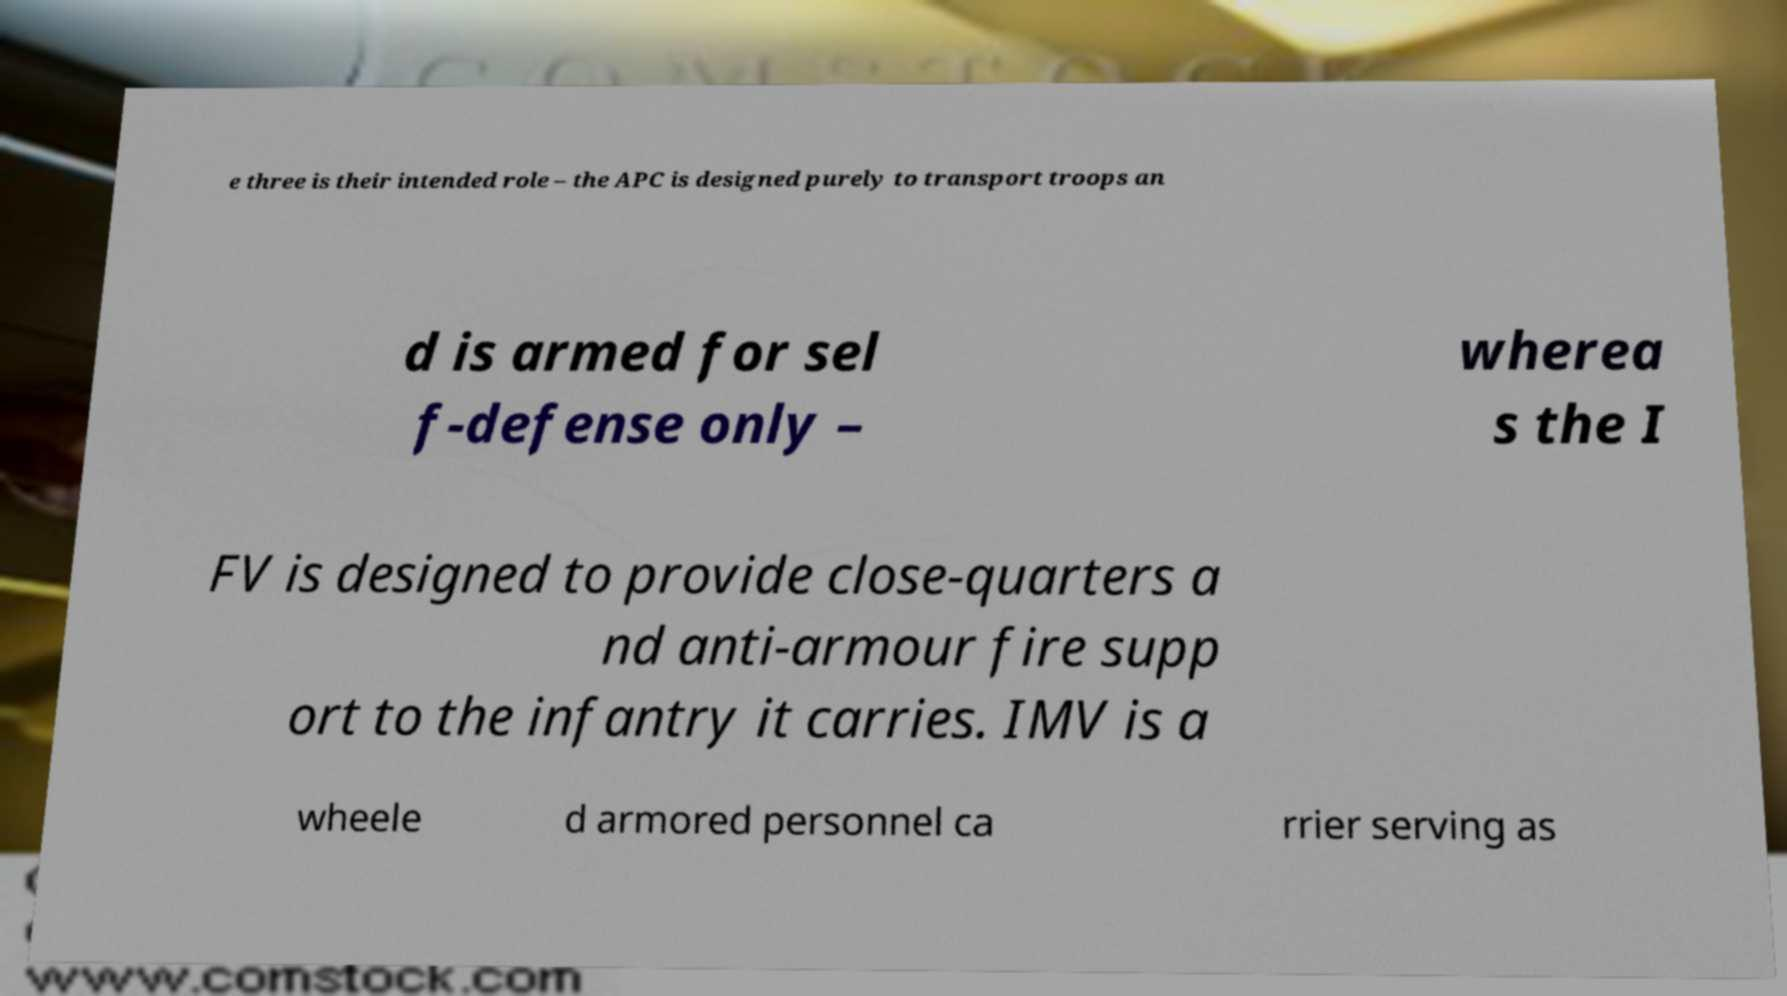What messages or text are displayed in this image? I need them in a readable, typed format. e three is their intended role – the APC is designed purely to transport troops an d is armed for sel f-defense only – wherea s the I FV is designed to provide close-quarters a nd anti-armour fire supp ort to the infantry it carries. IMV is a wheele d armored personnel ca rrier serving as 